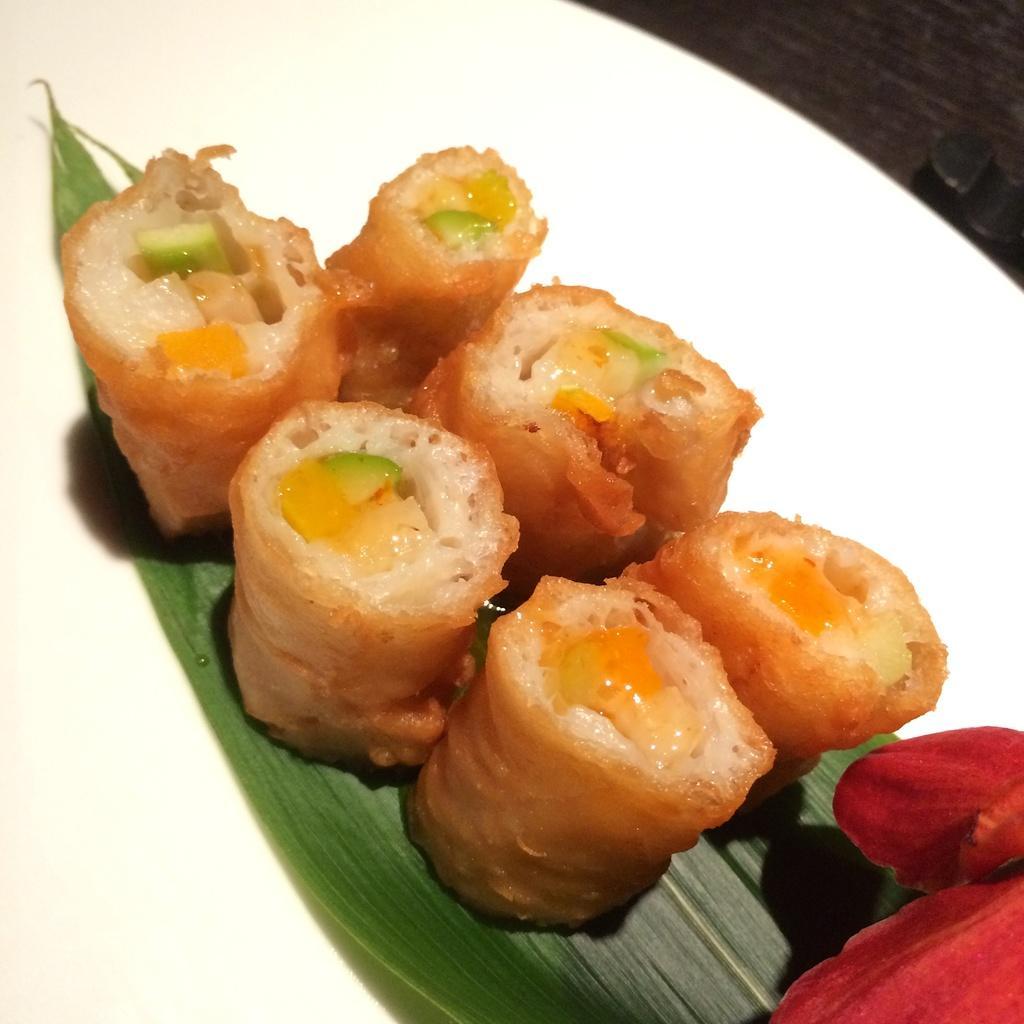How would you summarize this image in a sentence or two? In the picture I can see the plate. At the top of the plate I can see food items. 